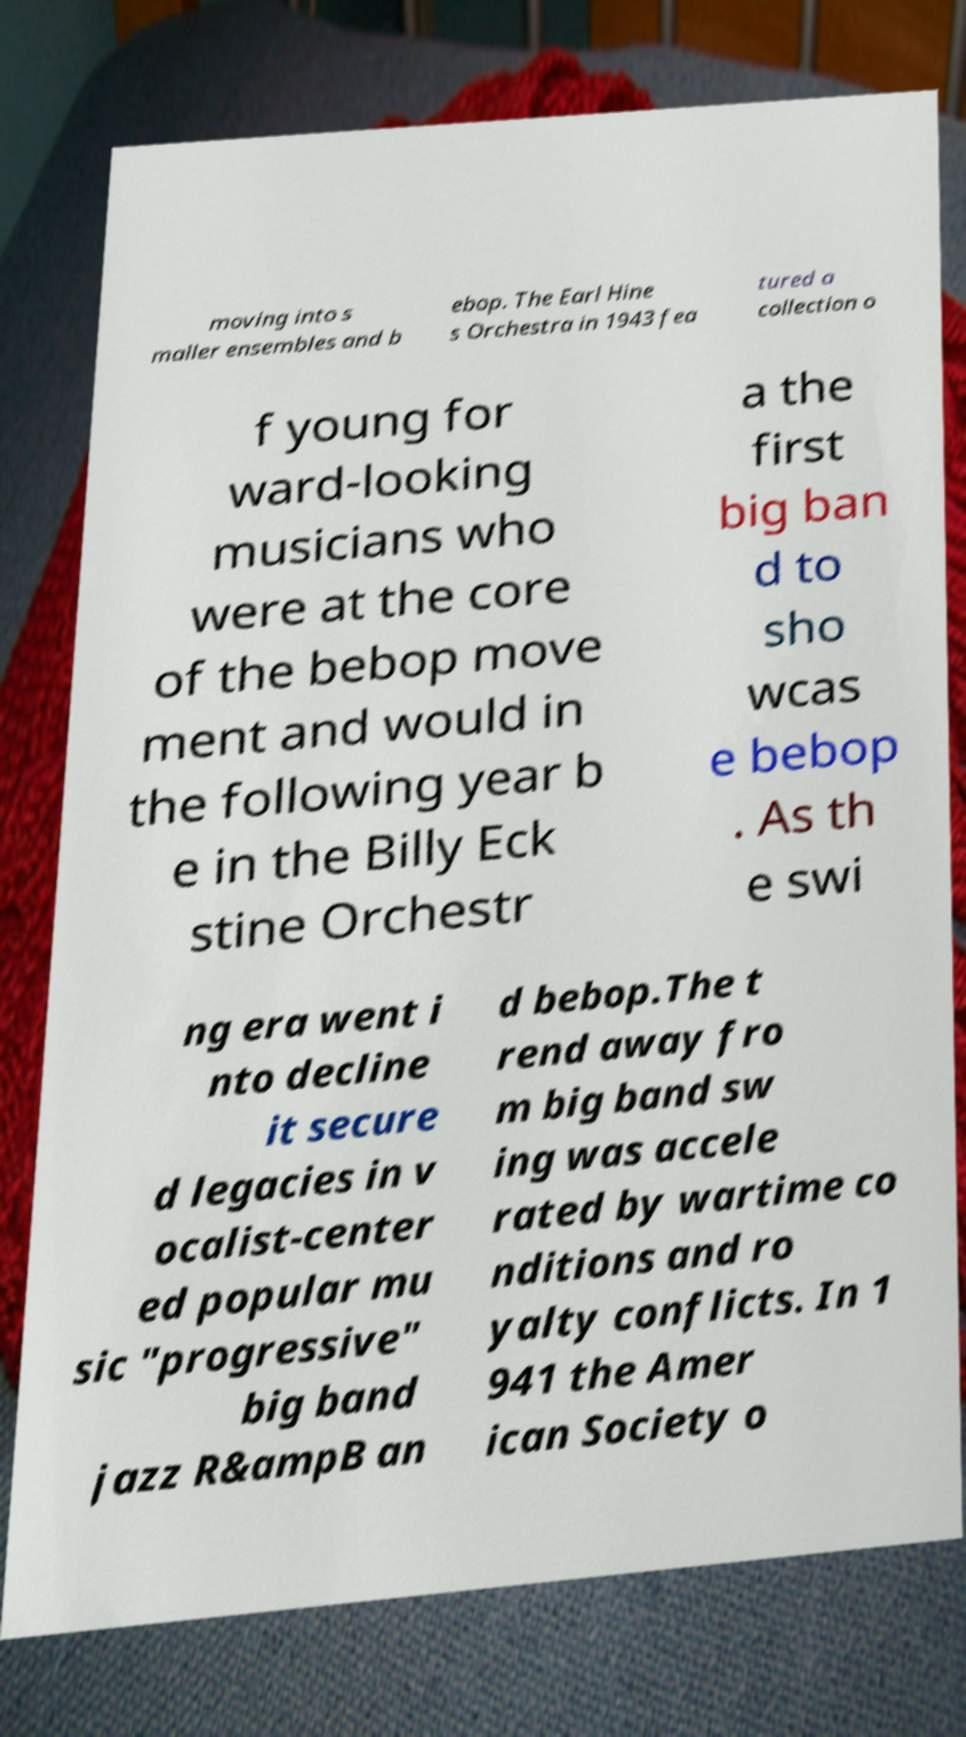Could you assist in decoding the text presented in this image and type it out clearly? moving into s maller ensembles and b ebop. The Earl Hine s Orchestra in 1943 fea tured a collection o f young for ward-looking musicians who were at the core of the bebop move ment and would in the following year b e in the Billy Eck stine Orchestr a the first big ban d to sho wcas e bebop . As th e swi ng era went i nto decline it secure d legacies in v ocalist-center ed popular mu sic "progressive" big band jazz R&ampB an d bebop.The t rend away fro m big band sw ing was accele rated by wartime co nditions and ro yalty conflicts. In 1 941 the Amer ican Society o 